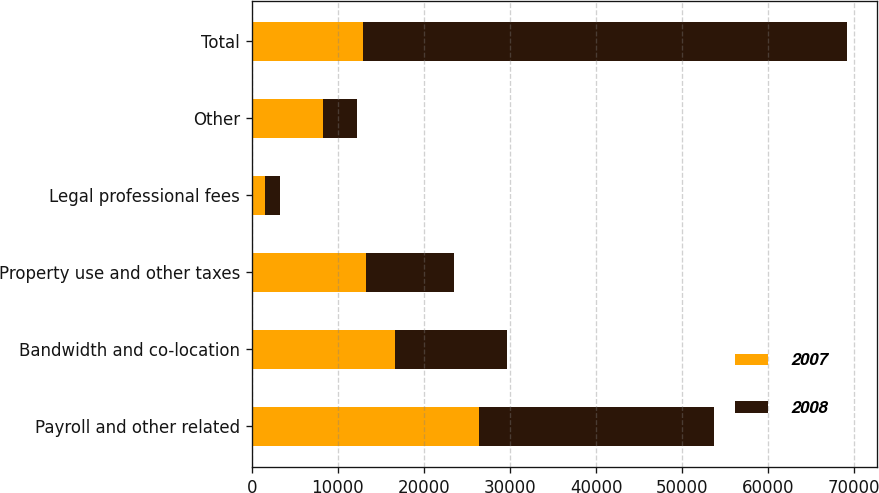Convert chart. <chart><loc_0><loc_0><loc_500><loc_500><stacked_bar_chart><ecel><fcel>Payroll and other related<fcel>Bandwidth and co-location<fcel>Property use and other taxes<fcel>Legal professional fees<fcel>Other<fcel>Total<nl><fcel>2007<fcel>26377<fcel>16642<fcel>13317<fcel>1475<fcel>8321<fcel>12968<nl><fcel>2008<fcel>27381<fcel>12968<fcel>10182<fcel>1781<fcel>3921<fcel>56233<nl></chart> 